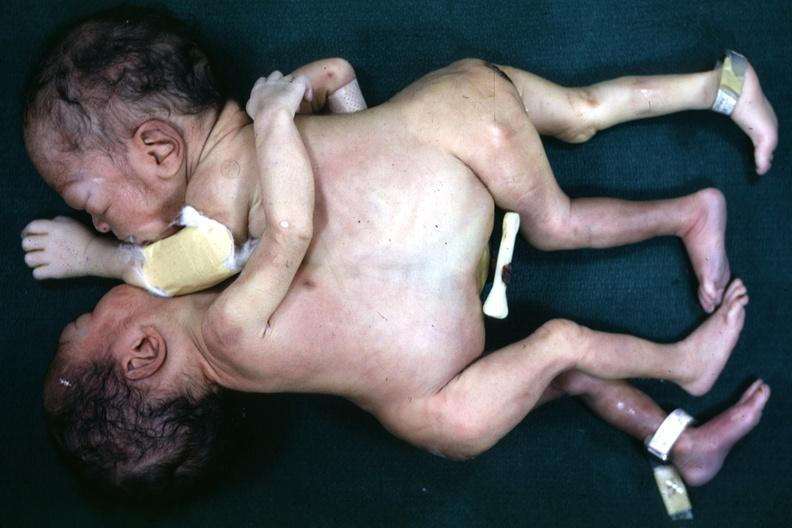does this image show view from side showing fusion lower chest and entire abdomen single umbilical cord?
Answer the question using a single word or phrase. Yes 